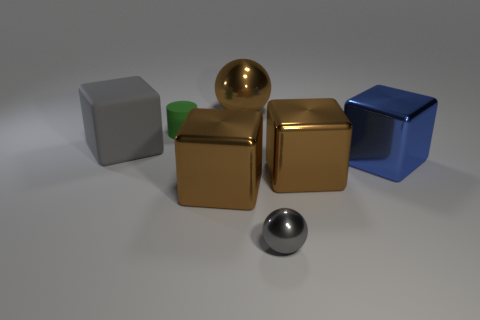Subtract all large rubber blocks. How many blocks are left? 3 Subtract all gray spheres. How many brown cubes are left? 2 Subtract 1 cubes. How many cubes are left? 3 Subtract all blue blocks. How many blocks are left? 3 Add 1 cyan rubber cubes. How many objects exist? 8 Add 5 gray objects. How many gray objects are left? 7 Add 1 large blue shiny cubes. How many large blue shiny cubes exist? 2 Subtract 0 brown cylinders. How many objects are left? 7 Subtract all cylinders. How many objects are left? 6 Subtract all purple spheres. Subtract all cyan blocks. How many spheres are left? 2 